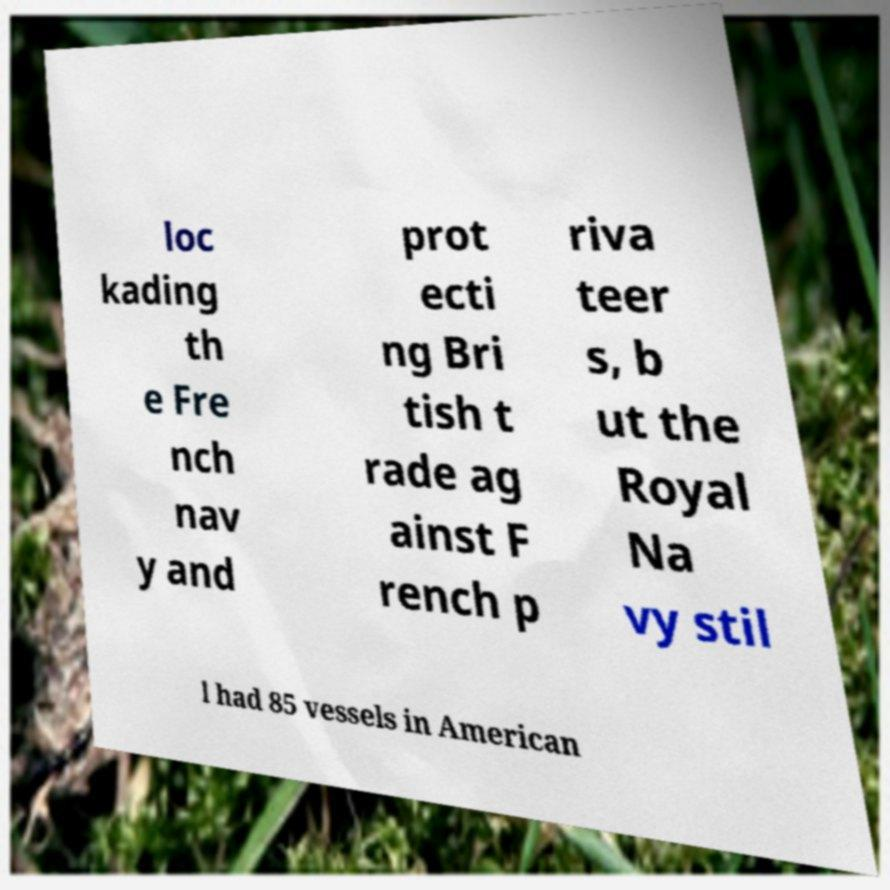Can you accurately transcribe the text from the provided image for me? loc kading th e Fre nch nav y and prot ecti ng Bri tish t rade ag ainst F rench p riva teer s, b ut the Royal Na vy stil l had 85 vessels in American 